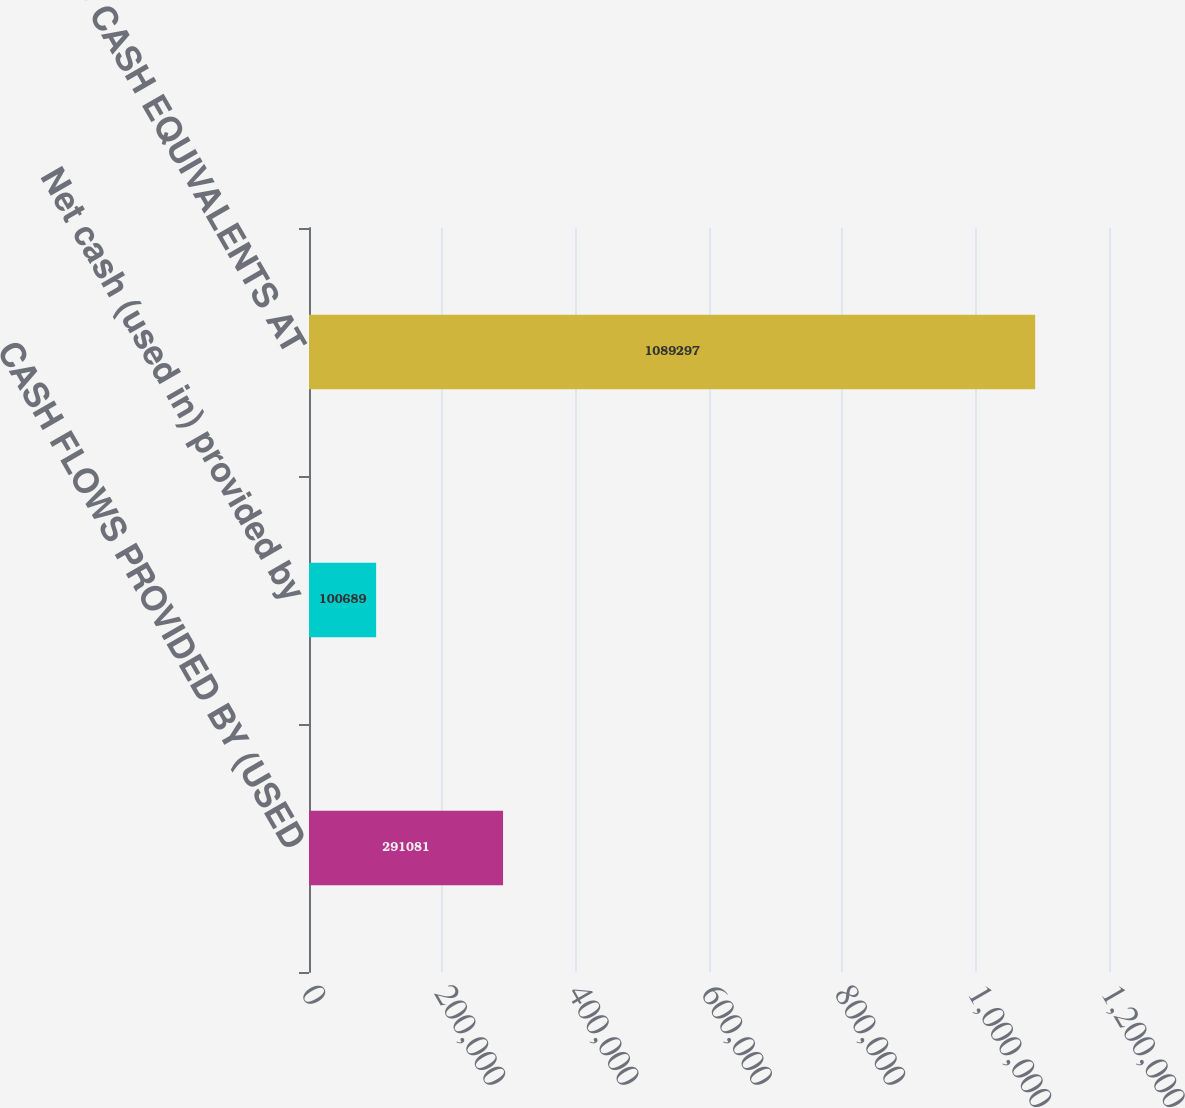Convert chart. <chart><loc_0><loc_0><loc_500><loc_500><bar_chart><fcel>CASH FLOWS PROVIDED BY (USED<fcel>Net cash (used in) provided by<fcel>CASH AND CASH EQUIVALENTS AT<nl><fcel>291081<fcel>100689<fcel>1.0893e+06<nl></chart> 